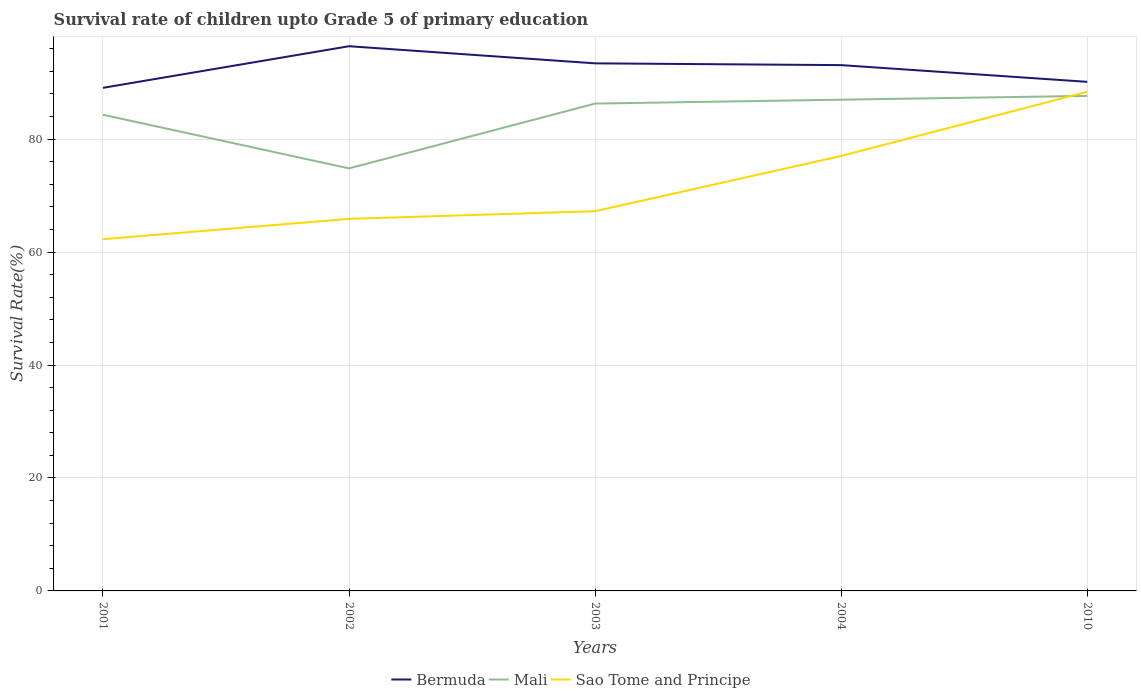How many different coloured lines are there?
Provide a succinct answer. 3. Is the number of lines equal to the number of legend labels?
Your answer should be very brief. Yes. Across all years, what is the maximum survival rate of children in Sao Tome and Principe?
Ensure brevity in your answer.  62.28. In which year was the survival rate of children in Bermuda maximum?
Your answer should be compact. 2001. What is the total survival rate of children in Mali in the graph?
Offer a terse response. -12.16. What is the difference between the highest and the second highest survival rate of children in Bermuda?
Keep it short and to the point. 7.37. What is the difference between the highest and the lowest survival rate of children in Sao Tome and Principe?
Give a very brief answer. 2. How many lines are there?
Offer a terse response. 3. How many years are there in the graph?
Your answer should be very brief. 5. What is the difference between two consecutive major ticks on the Y-axis?
Give a very brief answer. 20. Are the values on the major ticks of Y-axis written in scientific E-notation?
Keep it short and to the point. No. How many legend labels are there?
Provide a short and direct response. 3. What is the title of the graph?
Keep it short and to the point. Survival rate of children upto Grade 5 of primary education. What is the label or title of the Y-axis?
Your answer should be compact. Survival Rate(%). What is the Survival Rate(%) in Bermuda in 2001?
Give a very brief answer. 89.07. What is the Survival Rate(%) in Mali in 2001?
Give a very brief answer. 84.31. What is the Survival Rate(%) of Sao Tome and Principe in 2001?
Offer a very short reply. 62.28. What is the Survival Rate(%) of Bermuda in 2002?
Offer a terse response. 96.44. What is the Survival Rate(%) of Mali in 2002?
Make the answer very short. 74.81. What is the Survival Rate(%) in Sao Tome and Principe in 2002?
Make the answer very short. 65.87. What is the Survival Rate(%) of Bermuda in 2003?
Ensure brevity in your answer.  93.41. What is the Survival Rate(%) of Mali in 2003?
Keep it short and to the point. 86.29. What is the Survival Rate(%) in Sao Tome and Principe in 2003?
Give a very brief answer. 67.23. What is the Survival Rate(%) in Bermuda in 2004?
Provide a short and direct response. 93.1. What is the Survival Rate(%) in Mali in 2004?
Offer a terse response. 86.98. What is the Survival Rate(%) in Sao Tome and Principe in 2004?
Make the answer very short. 77.01. What is the Survival Rate(%) of Bermuda in 2010?
Your response must be concise. 90.13. What is the Survival Rate(%) in Mali in 2010?
Give a very brief answer. 87.65. What is the Survival Rate(%) of Sao Tome and Principe in 2010?
Offer a very short reply. 88.38. Across all years, what is the maximum Survival Rate(%) of Bermuda?
Ensure brevity in your answer.  96.44. Across all years, what is the maximum Survival Rate(%) of Mali?
Give a very brief answer. 87.65. Across all years, what is the maximum Survival Rate(%) in Sao Tome and Principe?
Ensure brevity in your answer.  88.38. Across all years, what is the minimum Survival Rate(%) of Bermuda?
Make the answer very short. 89.07. Across all years, what is the minimum Survival Rate(%) of Mali?
Make the answer very short. 74.81. Across all years, what is the minimum Survival Rate(%) of Sao Tome and Principe?
Offer a very short reply. 62.28. What is the total Survival Rate(%) of Bermuda in the graph?
Give a very brief answer. 462.16. What is the total Survival Rate(%) of Mali in the graph?
Keep it short and to the point. 420.04. What is the total Survival Rate(%) of Sao Tome and Principe in the graph?
Your response must be concise. 360.78. What is the difference between the Survival Rate(%) in Bermuda in 2001 and that in 2002?
Your answer should be very brief. -7.37. What is the difference between the Survival Rate(%) of Mali in 2001 and that in 2002?
Offer a terse response. 9.5. What is the difference between the Survival Rate(%) of Sao Tome and Principe in 2001 and that in 2002?
Give a very brief answer. -3.6. What is the difference between the Survival Rate(%) of Bermuda in 2001 and that in 2003?
Give a very brief answer. -4.34. What is the difference between the Survival Rate(%) of Mali in 2001 and that in 2003?
Give a very brief answer. -1.97. What is the difference between the Survival Rate(%) of Sao Tome and Principe in 2001 and that in 2003?
Offer a terse response. -4.95. What is the difference between the Survival Rate(%) of Bermuda in 2001 and that in 2004?
Make the answer very short. -4.02. What is the difference between the Survival Rate(%) in Mali in 2001 and that in 2004?
Make the answer very short. -2.66. What is the difference between the Survival Rate(%) in Sao Tome and Principe in 2001 and that in 2004?
Your answer should be very brief. -14.73. What is the difference between the Survival Rate(%) in Bermuda in 2001 and that in 2010?
Your response must be concise. -1.06. What is the difference between the Survival Rate(%) of Mali in 2001 and that in 2010?
Your answer should be very brief. -3.33. What is the difference between the Survival Rate(%) of Sao Tome and Principe in 2001 and that in 2010?
Give a very brief answer. -26.1. What is the difference between the Survival Rate(%) in Bermuda in 2002 and that in 2003?
Give a very brief answer. 3.03. What is the difference between the Survival Rate(%) of Mali in 2002 and that in 2003?
Make the answer very short. -11.47. What is the difference between the Survival Rate(%) in Sao Tome and Principe in 2002 and that in 2003?
Give a very brief answer. -1.36. What is the difference between the Survival Rate(%) of Bermuda in 2002 and that in 2004?
Ensure brevity in your answer.  3.35. What is the difference between the Survival Rate(%) in Mali in 2002 and that in 2004?
Make the answer very short. -12.16. What is the difference between the Survival Rate(%) of Sao Tome and Principe in 2002 and that in 2004?
Ensure brevity in your answer.  -11.14. What is the difference between the Survival Rate(%) of Bermuda in 2002 and that in 2010?
Provide a succinct answer. 6.31. What is the difference between the Survival Rate(%) in Mali in 2002 and that in 2010?
Provide a succinct answer. -12.84. What is the difference between the Survival Rate(%) in Sao Tome and Principe in 2002 and that in 2010?
Offer a very short reply. -22.5. What is the difference between the Survival Rate(%) of Bermuda in 2003 and that in 2004?
Keep it short and to the point. 0.32. What is the difference between the Survival Rate(%) of Mali in 2003 and that in 2004?
Your answer should be compact. -0.69. What is the difference between the Survival Rate(%) in Sao Tome and Principe in 2003 and that in 2004?
Make the answer very short. -9.78. What is the difference between the Survival Rate(%) in Bermuda in 2003 and that in 2010?
Provide a short and direct response. 3.28. What is the difference between the Survival Rate(%) of Mali in 2003 and that in 2010?
Your response must be concise. -1.36. What is the difference between the Survival Rate(%) of Sao Tome and Principe in 2003 and that in 2010?
Your answer should be compact. -21.15. What is the difference between the Survival Rate(%) in Bermuda in 2004 and that in 2010?
Keep it short and to the point. 2.96. What is the difference between the Survival Rate(%) of Mali in 2004 and that in 2010?
Provide a short and direct response. -0.67. What is the difference between the Survival Rate(%) in Sao Tome and Principe in 2004 and that in 2010?
Offer a terse response. -11.37. What is the difference between the Survival Rate(%) of Bermuda in 2001 and the Survival Rate(%) of Mali in 2002?
Offer a very short reply. 14.26. What is the difference between the Survival Rate(%) in Bermuda in 2001 and the Survival Rate(%) in Sao Tome and Principe in 2002?
Your answer should be compact. 23.2. What is the difference between the Survival Rate(%) of Mali in 2001 and the Survival Rate(%) of Sao Tome and Principe in 2002?
Offer a terse response. 18.44. What is the difference between the Survival Rate(%) of Bermuda in 2001 and the Survival Rate(%) of Mali in 2003?
Offer a terse response. 2.79. What is the difference between the Survival Rate(%) in Bermuda in 2001 and the Survival Rate(%) in Sao Tome and Principe in 2003?
Give a very brief answer. 21.84. What is the difference between the Survival Rate(%) of Mali in 2001 and the Survival Rate(%) of Sao Tome and Principe in 2003?
Offer a very short reply. 17.08. What is the difference between the Survival Rate(%) of Bermuda in 2001 and the Survival Rate(%) of Mali in 2004?
Offer a terse response. 2.1. What is the difference between the Survival Rate(%) of Bermuda in 2001 and the Survival Rate(%) of Sao Tome and Principe in 2004?
Your answer should be very brief. 12.06. What is the difference between the Survival Rate(%) in Mali in 2001 and the Survival Rate(%) in Sao Tome and Principe in 2004?
Offer a very short reply. 7.3. What is the difference between the Survival Rate(%) of Bermuda in 2001 and the Survival Rate(%) of Mali in 2010?
Keep it short and to the point. 1.43. What is the difference between the Survival Rate(%) of Bermuda in 2001 and the Survival Rate(%) of Sao Tome and Principe in 2010?
Give a very brief answer. 0.7. What is the difference between the Survival Rate(%) in Mali in 2001 and the Survival Rate(%) in Sao Tome and Principe in 2010?
Make the answer very short. -4.06. What is the difference between the Survival Rate(%) in Bermuda in 2002 and the Survival Rate(%) in Mali in 2003?
Provide a short and direct response. 10.15. What is the difference between the Survival Rate(%) in Bermuda in 2002 and the Survival Rate(%) in Sao Tome and Principe in 2003?
Give a very brief answer. 29.21. What is the difference between the Survival Rate(%) in Mali in 2002 and the Survival Rate(%) in Sao Tome and Principe in 2003?
Make the answer very short. 7.58. What is the difference between the Survival Rate(%) of Bermuda in 2002 and the Survival Rate(%) of Mali in 2004?
Offer a terse response. 9.47. What is the difference between the Survival Rate(%) in Bermuda in 2002 and the Survival Rate(%) in Sao Tome and Principe in 2004?
Make the answer very short. 19.43. What is the difference between the Survival Rate(%) in Mali in 2002 and the Survival Rate(%) in Sao Tome and Principe in 2004?
Give a very brief answer. -2.2. What is the difference between the Survival Rate(%) in Bermuda in 2002 and the Survival Rate(%) in Mali in 2010?
Provide a succinct answer. 8.79. What is the difference between the Survival Rate(%) of Bermuda in 2002 and the Survival Rate(%) of Sao Tome and Principe in 2010?
Ensure brevity in your answer.  8.06. What is the difference between the Survival Rate(%) of Mali in 2002 and the Survival Rate(%) of Sao Tome and Principe in 2010?
Keep it short and to the point. -13.57. What is the difference between the Survival Rate(%) of Bermuda in 2003 and the Survival Rate(%) of Mali in 2004?
Offer a very short reply. 6.43. What is the difference between the Survival Rate(%) of Bermuda in 2003 and the Survival Rate(%) of Sao Tome and Principe in 2004?
Provide a short and direct response. 16.4. What is the difference between the Survival Rate(%) of Mali in 2003 and the Survival Rate(%) of Sao Tome and Principe in 2004?
Make the answer very short. 9.28. What is the difference between the Survival Rate(%) of Bermuda in 2003 and the Survival Rate(%) of Mali in 2010?
Offer a terse response. 5.76. What is the difference between the Survival Rate(%) in Bermuda in 2003 and the Survival Rate(%) in Sao Tome and Principe in 2010?
Ensure brevity in your answer.  5.03. What is the difference between the Survival Rate(%) of Mali in 2003 and the Survival Rate(%) of Sao Tome and Principe in 2010?
Give a very brief answer. -2.09. What is the difference between the Survival Rate(%) in Bermuda in 2004 and the Survival Rate(%) in Mali in 2010?
Your response must be concise. 5.45. What is the difference between the Survival Rate(%) of Bermuda in 2004 and the Survival Rate(%) of Sao Tome and Principe in 2010?
Ensure brevity in your answer.  4.72. What is the difference between the Survival Rate(%) in Mali in 2004 and the Survival Rate(%) in Sao Tome and Principe in 2010?
Offer a very short reply. -1.4. What is the average Survival Rate(%) in Bermuda per year?
Keep it short and to the point. 92.43. What is the average Survival Rate(%) of Mali per year?
Ensure brevity in your answer.  84.01. What is the average Survival Rate(%) in Sao Tome and Principe per year?
Your response must be concise. 72.16. In the year 2001, what is the difference between the Survival Rate(%) of Bermuda and Survival Rate(%) of Mali?
Ensure brevity in your answer.  4.76. In the year 2001, what is the difference between the Survival Rate(%) of Bermuda and Survival Rate(%) of Sao Tome and Principe?
Provide a succinct answer. 26.8. In the year 2001, what is the difference between the Survival Rate(%) in Mali and Survival Rate(%) in Sao Tome and Principe?
Your answer should be compact. 22.04. In the year 2002, what is the difference between the Survival Rate(%) in Bermuda and Survival Rate(%) in Mali?
Your answer should be very brief. 21.63. In the year 2002, what is the difference between the Survival Rate(%) of Bermuda and Survival Rate(%) of Sao Tome and Principe?
Keep it short and to the point. 30.57. In the year 2002, what is the difference between the Survival Rate(%) in Mali and Survival Rate(%) in Sao Tome and Principe?
Offer a terse response. 8.94. In the year 2003, what is the difference between the Survival Rate(%) in Bermuda and Survival Rate(%) in Mali?
Offer a terse response. 7.12. In the year 2003, what is the difference between the Survival Rate(%) of Bermuda and Survival Rate(%) of Sao Tome and Principe?
Provide a succinct answer. 26.18. In the year 2003, what is the difference between the Survival Rate(%) of Mali and Survival Rate(%) of Sao Tome and Principe?
Keep it short and to the point. 19.06. In the year 2004, what is the difference between the Survival Rate(%) in Bermuda and Survival Rate(%) in Mali?
Provide a short and direct response. 6.12. In the year 2004, what is the difference between the Survival Rate(%) of Bermuda and Survival Rate(%) of Sao Tome and Principe?
Your response must be concise. 16.09. In the year 2004, what is the difference between the Survival Rate(%) in Mali and Survival Rate(%) in Sao Tome and Principe?
Your answer should be compact. 9.97. In the year 2010, what is the difference between the Survival Rate(%) of Bermuda and Survival Rate(%) of Mali?
Make the answer very short. 2.49. In the year 2010, what is the difference between the Survival Rate(%) of Bermuda and Survival Rate(%) of Sao Tome and Principe?
Keep it short and to the point. 1.76. In the year 2010, what is the difference between the Survival Rate(%) of Mali and Survival Rate(%) of Sao Tome and Principe?
Provide a succinct answer. -0.73. What is the ratio of the Survival Rate(%) in Bermuda in 2001 to that in 2002?
Offer a very short reply. 0.92. What is the ratio of the Survival Rate(%) of Mali in 2001 to that in 2002?
Your answer should be very brief. 1.13. What is the ratio of the Survival Rate(%) in Sao Tome and Principe in 2001 to that in 2002?
Provide a short and direct response. 0.95. What is the ratio of the Survival Rate(%) of Bermuda in 2001 to that in 2003?
Offer a very short reply. 0.95. What is the ratio of the Survival Rate(%) in Mali in 2001 to that in 2003?
Your answer should be compact. 0.98. What is the ratio of the Survival Rate(%) of Sao Tome and Principe in 2001 to that in 2003?
Make the answer very short. 0.93. What is the ratio of the Survival Rate(%) in Bermuda in 2001 to that in 2004?
Provide a succinct answer. 0.96. What is the ratio of the Survival Rate(%) in Mali in 2001 to that in 2004?
Your answer should be compact. 0.97. What is the ratio of the Survival Rate(%) of Sao Tome and Principe in 2001 to that in 2004?
Offer a very short reply. 0.81. What is the ratio of the Survival Rate(%) in Bermuda in 2001 to that in 2010?
Ensure brevity in your answer.  0.99. What is the ratio of the Survival Rate(%) of Mali in 2001 to that in 2010?
Ensure brevity in your answer.  0.96. What is the ratio of the Survival Rate(%) of Sao Tome and Principe in 2001 to that in 2010?
Provide a short and direct response. 0.7. What is the ratio of the Survival Rate(%) of Bermuda in 2002 to that in 2003?
Provide a succinct answer. 1.03. What is the ratio of the Survival Rate(%) of Mali in 2002 to that in 2003?
Provide a succinct answer. 0.87. What is the ratio of the Survival Rate(%) in Sao Tome and Principe in 2002 to that in 2003?
Give a very brief answer. 0.98. What is the ratio of the Survival Rate(%) of Bermuda in 2002 to that in 2004?
Offer a very short reply. 1.04. What is the ratio of the Survival Rate(%) of Mali in 2002 to that in 2004?
Provide a succinct answer. 0.86. What is the ratio of the Survival Rate(%) of Sao Tome and Principe in 2002 to that in 2004?
Your answer should be very brief. 0.86. What is the ratio of the Survival Rate(%) of Bermuda in 2002 to that in 2010?
Make the answer very short. 1.07. What is the ratio of the Survival Rate(%) of Mali in 2002 to that in 2010?
Your response must be concise. 0.85. What is the ratio of the Survival Rate(%) of Sao Tome and Principe in 2002 to that in 2010?
Your answer should be compact. 0.75. What is the ratio of the Survival Rate(%) in Sao Tome and Principe in 2003 to that in 2004?
Provide a short and direct response. 0.87. What is the ratio of the Survival Rate(%) in Bermuda in 2003 to that in 2010?
Provide a succinct answer. 1.04. What is the ratio of the Survival Rate(%) of Mali in 2003 to that in 2010?
Keep it short and to the point. 0.98. What is the ratio of the Survival Rate(%) in Sao Tome and Principe in 2003 to that in 2010?
Make the answer very short. 0.76. What is the ratio of the Survival Rate(%) of Bermuda in 2004 to that in 2010?
Your response must be concise. 1.03. What is the ratio of the Survival Rate(%) of Mali in 2004 to that in 2010?
Ensure brevity in your answer.  0.99. What is the ratio of the Survival Rate(%) of Sao Tome and Principe in 2004 to that in 2010?
Ensure brevity in your answer.  0.87. What is the difference between the highest and the second highest Survival Rate(%) in Bermuda?
Ensure brevity in your answer.  3.03. What is the difference between the highest and the second highest Survival Rate(%) of Mali?
Offer a terse response. 0.67. What is the difference between the highest and the second highest Survival Rate(%) in Sao Tome and Principe?
Offer a very short reply. 11.37. What is the difference between the highest and the lowest Survival Rate(%) of Bermuda?
Ensure brevity in your answer.  7.37. What is the difference between the highest and the lowest Survival Rate(%) in Mali?
Your response must be concise. 12.84. What is the difference between the highest and the lowest Survival Rate(%) in Sao Tome and Principe?
Your answer should be very brief. 26.1. 